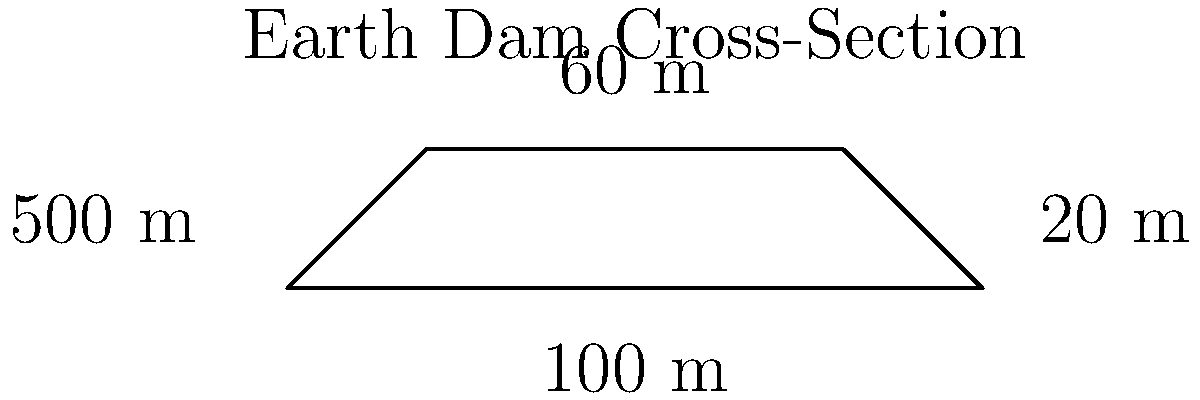As a descendant of Enright settlers, you're tasked with estimating the volume of an earth dam for a local reservoir project. The dam has a trapezoidal cross-section with the following dimensions:

- Base width: 100 m
- Top width: 60 m
- Height: 20 m
- Length: 500 m

Calculate the volume of the earth dam in cubic meters. To calculate the volume of the earth dam, we'll follow these steps:

1) First, we need to find the area of the trapezoidal cross-section. The formula for the area of a trapezoid is:

   $$A = \frac{1}{2}(b_1 + b_2)h$$

   where $A$ is the area, $b_1$ and $b_2$ are the parallel sides, and $h$ is the height.

2) Substituting our values:
   $$A = \frac{1}{2}(100 + 60) \times 20$$
   $$A = \frac{1}{2} \times 160 \times 20 = 1600 \text{ m}^2$$

3) Now that we have the cross-sectional area, we can calculate the volume by multiplying this area by the length of the dam:

   $$V = A \times L$$

   where $V$ is the volume and $L$ is the length.

4) Substituting our values:
   $$V = 1600 \times 500 = 800,000 \text{ m}^3$$

Therefore, the volume of the earth dam is 800,000 cubic meters.
Answer: 800,000 m³ 